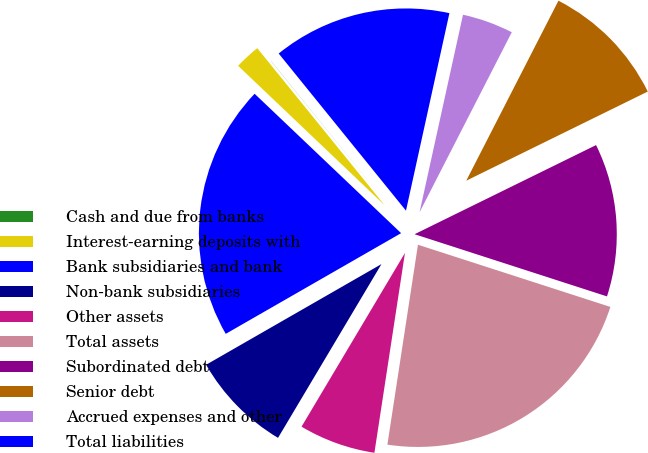<chart> <loc_0><loc_0><loc_500><loc_500><pie_chart><fcel>Cash and due from banks<fcel>Interest-earning deposits with<fcel>Bank subsidiaries and bank<fcel>Non-bank subsidiaries<fcel>Other assets<fcel>Total assets<fcel>Subordinated debt<fcel>Senior debt<fcel>Accrued expenses and other<fcel>Total liabilities<nl><fcel>0.01%<fcel>2.05%<fcel>20.4%<fcel>8.16%<fcel>6.13%<fcel>22.44%<fcel>12.24%<fcel>10.2%<fcel>4.09%<fcel>14.28%<nl></chart> 